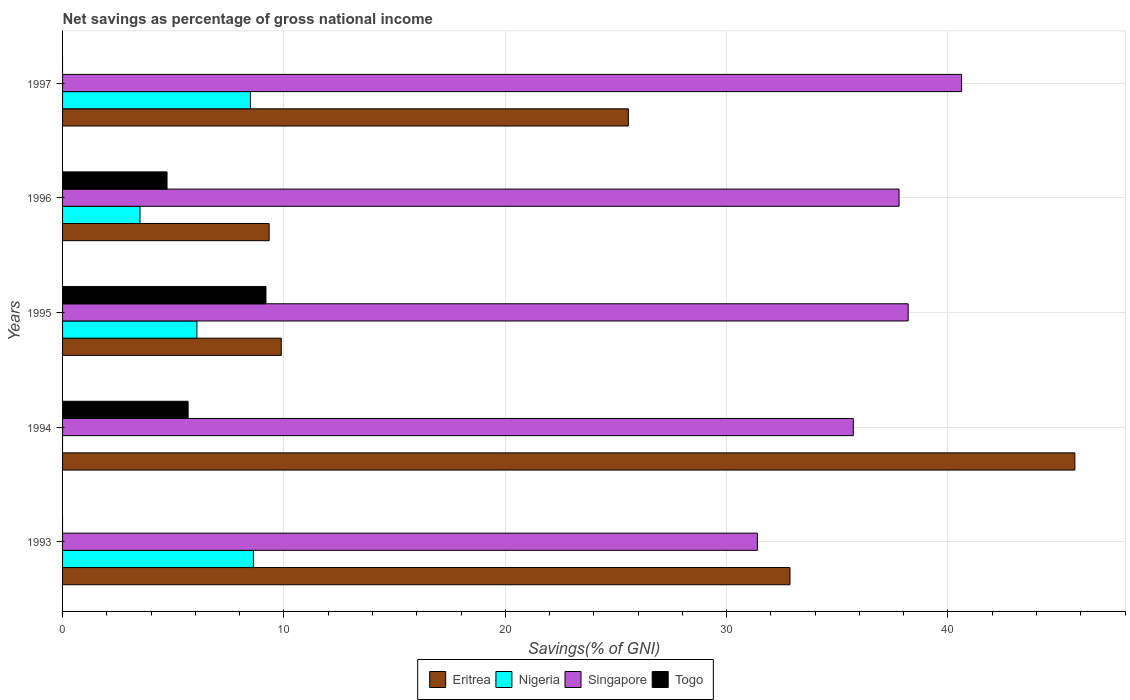How many bars are there on the 3rd tick from the top?
Give a very brief answer. 4. How many bars are there on the 5th tick from the bottom?
Provide a short and direct response. 3. What is the label of the 5th group of bars from the top?
Your answer should be compact. 1993. What is the total savings in Eritrea in 1995?
Provide a succinct answer. 9.88. Across all years, what is the maximum total savings in Togo?
Provide a succinct answer. 9.19. In which year was the total savings in Singapore maximum?
Make the answer very short. 1997. What is the total total savings in Singapore in the graph?
Offer a terse response. 183.72. What is the difference between the total savings in Eritrea in 1993 and that in 1995?
Give a very brief answer. 22.98. What is the difference between the total savings in Singapore in 1996 and the total savings in Nigeria in 1995?
Provide a succinct answer. 31.72. What is the average total savings in Eritrea per year?
Ensure brevity in your answer.  24.67. In the year 1994, what is the difference between the total savings in Togo and total savings in Singapore?
Your response must be concise. -30.05. In how many years, is the total savings in Singapore greater than 14 %?
Offer a terse response. 5. What is the ratio of the total savings in Eritrea in 1994 to that in 1996?
Ensure brevity in your answer.  4.9. What is the difference between the highest and the second highest total savings in Togo?
Ensure brevity in your answer.  3.52. What is the difference between the highest and the lowest total savings in Singapore?
Ensure brevity in your answer.  9.23. Is the sum of the total savings in Singapore in 1993 and 1994 greater than the maximum total savings in Togo across all years?
Offer a terse response. Yes. Is it the case that in every year, the sum of the total savings in Eritrea and total savings in Nigeria is greater than the total savings in Singapore?
Your response must be concise. No. How many bars are there?
Offer a very short reply. 17. Are all the bars in the graph horizontal?
Offer a terse response. Yes. Does the graph contain any zero values?
Provide a succinct answer. Yes. Does the graph contain grids?
Ensure brevity in your answer.  Yes. How many legend labels are there?
Provide a succinct answer. 4. What is the title of the graph?
Your answer should be very brief. Net savings as percentage of gross national income. Does "Other small states" appear as one of the legend labels in the graph?
Ensure brevity in your answer.  No. What is the label or title of the X-axis?
Make the answer very short. Savings(% of GNI). What is the label or title of the Y-axis?
Make the answer very short. Years. What is the Savings(% of GNI) in Eritrea in 1993?
Keep it short and to the point. 32.86. What is the Savings(% of GNI) of Nigeria in 1993?
Your response must be concise. 8.62. What is the Savings(% of GNI) in Singapore in 1993?
Offer a very short reply. 31.39. What is the Savings(% of GNI) of Togo in 1993?
Keep it short and to the point. 0. What is the Savings(% of GNI) of Eritrea in 1994?
Offer a very short reply. 45.73. What is the Savings(% of GNI) in Nigeria in 1994?
Provide a short and direct response. 0. What is the Savings(% of GNI) of Singapore in 1994?
Your answer should be compact. 35.72. What is the Savings(% of GNI) in Togo in 1994?
Your answer should be very brief. 5.67. What is the Savings(% of GNI) in Eritrea in 1995?
Your answer should be very brief. 9.88. What is the Savings(% of GNI) of Nigeria in 1995?
Your response must be concise. 6.07. What is the Savings(% of GNI) in Singapore in 1995?
Offer a terse response. 38.2. What is the Savings(% of GNI) in Togo in 1995?
Keep it short and to the point. 9.19. What is the Savings(% of GNI) of Eritrea in 1996?
Offer a terse response. 9.33. What is the Savings(% of GNI) of Nigeria in 1996?
Ensure brevity in your answer.  3.5. What is the Savings(% of GNI) of Singapore in 1996?
Offer a very short reply. 37.79. What is the Savings(% of GNI) of Togo in 1996?
Provide a succinct answer. 4.72. What is the Savings(% of GNI) in Eritrea in 1997?
Your response must be concise. 25.56. What is the Savings(% of GNI) in Nigeria in 1997?
Offer a terse response. 8.49. What is the Savings(% of GNI) of Singapore in 1997?
Keep it short and to the point. 40.62. What is the Savings(% of GNI) of Togo in 1997?
Your answer should be very brief. 0. Across all years, what is the maximum Savings(% of GNI) of Eritrea?
Your answer should be very brief. 45.73. Across all years, what is the maximum Savings(% of GNI) of Nigeria?
Your answer should be very brief. 8.62. Across all years, what is the maximum Savings(% of GNI) of Singapore?
Give a very brief answer. 40.62. Across all years, what is the maximum Savings(% of GNI) in Togo?
Give a very brief answer. 9.19. Across all years, what is the minimum Savings(% of GNI) in Eritrea?
Offer a very short reply. 9.33. Across all years, what is the minimum Savings(% of GNI) in Singapore?
Provide a short and direct response. 31.39. Across all years, what is the minimum Savings(% of GNI) in Togo?
Your answer should be very brief. 0. What is the total Savings(% of GNI) in Eritrea in the graph?
Keep it short and to the point. 123.37. What is the total Savings(% of GNI) in Nigeria in the graph?
Provide a short and direct response. 26.68. What is the total Savings(% of GNI) of Singapore in the graph?
Provide a short and direct response. 183.72. What is the total Savings(% of GNI) in Togo in the graph?
Ensure brevity in your answer.  19.58. What is the difference between the Savings(% of GNI) in Eritrea in 1993 and that in 1994?
Keep it short and to the point. -12.87. What is the difference between the Savings(% of GNI) of Singapore in 1993 and that in 1994?
Your answer should be compact. -4.33. What is the difference between the Savings(% of GNI) of Eritrea in 1993 and that in 1995?
Ensure brevity in your answer.  22.98. What is the difference between the Savings(% of GNI) in Nigeria in 1993 and that in 1995?
Provide a succinct answer. 2.55. What is the difference between the Savings(% of GNI) of Singapore in 1993 and that in 1995?
Make the answer very short. -6.81. What is the difference between the Savings(% of GNI) in Eritrea in 1993 and that in 1996?
Provide a short and direct response. 23.53. What is the difference between the Savings(% of GNI) of Nigeria in 1993 and that in 1996?
Make the answer very short. 5.12. What is the difference between the Savings(% of GNI) of Singapore in 1993 and that in 1996?
Keep it short and to the point. -6.4. What is the difference between the Savings(% of GNI) in Eritrea in 1993 and that in 1997?
Offer a very short reply. 7.3. What is the difference between the Savings(% of GNI) of Nigeria in 1993 and that in 1997?
Ensure brevity in your answer.  0.14. What is the difference between the Savings(% of GNI) in Singapore in 1993 and that in 1997?
Ensure brevity in your answer.  -9.23. What is the difference between the Savings(% of GNI) in Eritrea in 1994 and that in 1995?
Offer a terse response. 35.85. What is the difference between the Savings(% of GNI) in Singapore in 1994 and that in 1995?
Provide a succinct answer. -2.48. What is the difference between the Savings(% of GNI) of Togo in 1994 and that in 1995?
Your response must be concise. -3.52. What is the difference between the Savings(% of GNI) of Eritrea in 1994 and that in 1996?
Make the answer very short. 36.4. What is the difference between the Savings(% of GNI) in Singapore in 1994 and that in 1996?
Offer a terse response. -2.07. What is the difference between the Savings(% of GNI) of Togo in 1994 and that in 1996?
Your response must be concise. 0.95. What is the difference between the Savings(% of GNI) in Eritrea in 1994 and that in 1997?
Your response must be concise. 20.17. What is the difference between the Savings(% of GNI) of Singapore in 1994 and that in 1997?
Your answer should be compact. -4.89. What is the difference between the Savings(% of GNI) of Eritrea in 1995 and that in 1996?
Provide a succinct answer. 0.55. What is the difference between the Savings(% of GNI) of Nigeria in 1995 and that in 1996?
Give a very brief answer. 2.57. What is the difference between the Savings(% of GNI) of Singapore in 1995 and that in 1996?
Keep it short and to the point. 0.41. What is the difference between the Savings(% of GNI) in Togo in 1995 and that in 1996?
Your answer should be very brief. 4.47. What is the difference between the Savings(% of GNI) in Eritrea in 1995 and that in 1997?
Give a very brief answer. -15.68. What is the difference between the Savings(% of GNI) of Nigeria in 1995 and that in 1997?
Ensure brevity in your answer.  -2.42. What is the difference between the Savings(% of GNI) of Singapore in 1995 and that in 1997?
Your answer should be very brief. -2.41. What is the difference between the Savings(% of GNI) of Eritrea in 1996 and that in 1997?
Offer a very short reply. -16.23. What is the difference between the Savings(% of GNI) of Nigeria in 1996 and that in 1997?
Ensure brevity in your answer.  -4.99. What is the difference between the Savings(% of GNI) of Singapore in 1996 and that in 1997?
Keep it short and to the point. -2.83. What is the difference between the Savings(% of GNI) of Eritrea in 1993 and the Savings(% of GNI) of Singapore in 1994?
Provide a short and direct response. -2.86. What is the difference between the Savings(% of GNI) in Eritrea in 1993 and the Savings(% of GNI) in Togo in 1994?
Ensure brevity in your answer.  27.19. What is the difference between the Savings(% of GNI) in Nigeria in 1993 and the Savings(% of GNI) in Singapore in 1994?
Offer a terse response. -27.1. What is the difference between the Savings(% of GNI) of Nigeria in 1993 and the Savings(% of GNI) of Togo in 1994?
Your answer should be compact. 2.95. What is the difference between the Savings(% of GNI) of Singapore in 1993 and the Savings(% of GNI) of Togo in 1994?
Offer a terse response. 25.72. What is the difference between the Savings(% of GNI) in Eritrea in 1993 and the Savings(% of GNI) in Nigeria in 1995?
Your answer should be compact. 26.79. What is the difference between the Savings(% of GNI) of Eritrea in 1993 and the Savings(% of GNI) of Singapore in 1995?
Your answer should be very brief. -5.34. What is the difference between the Savings(% of GNI) in Eritrea in 1993 and the Savings(% of GNI) in Togo in 1995?
Make the answer very short. 23.67. What is the difference between the Savings(% of GNI) of Nigeria in 1993 and the Savings(% of GNI) of Singapore in 1995?
Offer a very short reply. -29.58. What is the difference between the Savings(% of GNI) of Nigeria in 1993 and the Savings(% of GNI) of Togo in 1995?
Keep it short and to the point. -0.57. What is the difference between the Savings(% of GNI) of Singapore in 1993 and the Savings(% of GNI) of Togo in 1995?
Keep it short and to the point. 22.2. What is the difference between the Savings(% of GNI) of Eritrea in 1993 and the Savings(% of GNI) of Nigeria in 1996?
Keep it short and to the point. 29.36. What is the difference between the Savings(% of GNI) in Eritrea in 1993 and the Savings(% of GNI) in Singapore in 1996?
Provide a short and direct response. -4.93. What is the difference between the Savings(% of GNI) of Eritrea in 1993 and the Savings(% of GNI) of Togo in 1996?
Offer a terse response. 28.14. What is the difference between the Savings(% of GNI) in Nigeria in 1993 and the Savings(% of GNI) in Singapore in 1996?
Your response must be concise. -29.17. What is the difference between the Savings(% of GNI) in Nigeria in 1993 and the Savings(% of GNI) in Togo in 1996?
Your response must be concise. 3.9. What is the difference between the Savings(% of GNI) of Singapore in 1993 and the Savings(% of GNI) of Togo in 1996?
Offer a terse response. 26.67. What is the difference between the Savings(% of GNI) in Eritrea in 1993 and the Savings(% of GNI) in Nigeria in 1997?
Your answer should be very brief. 24.38. What is the difference between the Savings(% of GNI) of Eritrea in 1993 and the Savings(% of GNI) of Singapore in 1997?
Ensure brevity in your answer.  -7.75. What is the difference between the Savings(% of GNI) of Nigeria in 1993 and the Savings(% of GNI) of Singapore in 1997?
Keep it short and to the point. -31.99. What is the difference between the Savings(% of GNI) of Eritrea in 1994 and the Savings(% of GNI) of Nigeria in 1995?
Make the answer very short. 39.66. What is the difference between the Savings(% of GNI) of Eritrea in 1994 and the Savings(% of GNI) of Singapore in 1995?
Give a very brief answer. 7.53. What is the difference between the Savings(% of GNI) in Eritrea in 1994 and the Savings(% of GNI) in Togo in 1995?
Make the answer very short. 36.54. What is the difference between the Savings(% of GNI) in Singapore in 1994 and the Savings(% of GNI) in Togo in 1995?
Your answer should be compact. 26.53. What is the difference between the Savings(% of GNI) in Eritrea in 1994 and the Savings(% of GNI) in Nigeria in 1996?
Your answer should be compact. 42.23. What is the difference between the Savings(% of GNI) of Eritrea in 1994 and the Savings(% of GNI) of Singapore in 1996?
Keep it short and to the point. 7.94. What is the difference between the Savings(% of GNI) of Eritrea in 1994 and the Savings(% of GNI) of Togo in 1996?
Give a very brief answer. 41.01. What is the difference between the Savings(% of GNI) of Singapore in 1994 and the Savings(% of GNI) of Togo in 1996?
Provide a short and direct response. 31. What is the difference between the Savings(% of GNI) in Eritrea in 1994 and the Savings(% of GNI) in Nigeria in 1997?
Offer a very short reply. 37.25. What is the difference between the Savings(% of GNI) in Eritrea in 1994 and the Savings(% of GNI) in Singapore in 1997?
Ensure brevity in your answer.  5.12. What is the difference between the Savings(% of GNI) of Eritrea in 1995 and the Savings(% of GNI) of Nigeria in 1996?
Your response must be concise. 6.38. What is the difference between the Savings(% of GNI) in Eritrea in 1995 and the Savings(% of GNI) in Singapore in 1996?
Provide a short and direct response. -27.91. What is the difference between the Savings(% of GNI) in Eritrea in 1995 and the Savings(% of GNI) in Togo in 1996?
Your response must be concise. 5.16. What is the difference between the Savings(% of GNI) of Nigeria in 1995 and the Savings(% of GNI) of Singapore in 1996?
Ensure brevity in your answer.  -31.72. What is the difference between the Savings(% of GNI) of Nigeria in 1995 and the Savings(% of GNI) of Togo in 1996?
Give a very brief answer. 1.35. What is the difference between the Savings(% of GNI) of Singapore in 1995 and the Savings(% of GNI) of Togo in 1996?
Provide a succinct answer. 33.48. What is the difference between the Savings(% of GNI) of Eritrea in 1995 and the Savings(% of GNI) of Nigeria in 1997?
Keep it short and to the point. 1.4. What is the difference between the Savings(% of GNI) in Eritrea in 1995 and the Savings(% of GNI) in Singapore in 1997?
Make the answer very short. -30.74. What is the difference between the Savings(% of GNI) of Nigeria in 1995 and the Savings(% of GNI) of Singapore in 1997?
Your answer should be compact. -34.55. What is the difference between the Savings(% of GNI) in Eritrea in 1996 and the Savings(% of GNI) in Nigeria in 1997?
Provide a succinct answer. 0.85. What is the difference between the Savings(% of GNI) of Eritrea in 1996 and the Savings(% of GNI) of Singapore in 1997?
Your response must be concise. -31.28. What is the difference between the Savings(% of GNI) of Nigeria in 1996 and the Savings(% of GNI) of Singapore in 1997?
Provide a succinct answer. -37.12. What is the average Savings(% of GNI) of Eritrea per year?
Provide a short and direct response. 24.67. What is the average Savings(% of GNI) in Nigeria per year?
Provide a short and direct response. 5.34. What is the average Savings(% of GNI) in Singapore per year?
Make the answer very short. 36.74. What is the average Savings(% of GNI) of Togo per year?
Make the answer very short. 3.92. In the year 1993, what is the difference between the Savings(% of GNI) of Eritrea and Savings(% of GNI) of Nigeria?
Ensure brevity in your answer.  24.24. In the year 1993, what is the difference between the Savings(% of GNI) of Eritrea and Savings(% of GNI) of Singapore?
Your response must be concise. 1.47. In the year 1993, what is the difference between the Savings(% of GNI) in Nigeria and Savings(% of GNI) in Singapore?
Keep it short and to the point. -22.77. In the year 1994, what is the difference between the Savings(% of GNI) in Eritrea and Savings(% of GNI) in Singapore?
Your response must be concise. 10.01. In the year 1994, what is the difference between the Savings(% of GNI) in Eritrea and Savings(% of GNI) in Togo?
Ensure brevity in your answer.  40.06. In the year 1994, what is the difference between the Savings(% of GNI) in Singapore and Savings(% of GNI) in Togo?
Provide a short and direct response. 30.05. In the year 1995, what is the difference between the Savings(% of GNI) in Eritrea and Savings(% of GNI) in Nigeria?
Provide a succinct answer. 3.81. In the year 1995, what is the difference between the Savings(% of GNI) of Eritrea and Savings(% of GNI) of Singapore?
Ensure brevity in your answer.  -28.32. In the year 1995, what is the difference between the Savings(% of GNI) of Eritrea and Savings(% of GNI) of Togo?
Ensure brevity in your answer.  0.69. In the year 1995, what is the difference between the Savings(% of GNI) in Nigeria and Savings(% of GNI) in Singapore?
Your answer should be compact. -32.13. In the year 1995, what is the difference between the Savings(% of GNI) in Nigeria and Savings(% of GNI) in Togo?
Ensure brevity in your answer.  -3.12. In the year 1995, what is the difference between the Savings(% of GNI) in Singapore and Savings(% of GNI) in Togo?
Provide a short and direct response. 29.01. In the year 1996, what is the difference between the Savings(% of GNI) of Eritrea and Savings(% of GNI) of Nigeria?
Ensure brevity in your answer.  5.83. In the year 1996, what is the difference between the Savings(% of GNI) of Eritrea and Savings(% of GNI) of Singapore?
Your answer should be compact. -28.46. In the year 1996, what is the difference between the Savings(% of GNI) of Eritrea and Savings(% of GNI) of Togo?
Keep it short and to the point. 4.61. In the year 1996, what is the difference between the Savings(% of GNI) of Nigeria and Savings(% of GNI) of Singapore?
Give a very brief answer. -34.29. In the year 1996, what is the difference between the Savings(% of GNI) in Nigeria and Savings(% of GNI) in Togo?
Provide a succinct answer. -1.22. In the year 1996, what is the difference between the Savings(% of GNI) of Singapore and Savings(% of GNI) of Togo?
Your response must be concise. 33.07. In the year 1997, what is the difference between the Savings(% of GNI) in Eritrea and Savings(% of GNI) in Nigeria?
Offer a terse response. 17.08. In the year 1997, what is the difference between the Savings(% of GNI) of Eritrea and Savings(% of GNI) of Singapore?
Your answer should be very brief. -15.05. In the year 1997, what is the difference between the Savings(% of GNI) in Nigeria and Savings(% of GNI) in Singapore?
Your answer should be compact. -32.13. What is the ratio of the Savings(% of GNI) in Eritrea in 1993 to that in 1994?
Ensure brevity in your answer.  0.72. What is the ratio of the Savings(% of GNI) of Singapore in 1993 to that in 1994?
Provide a short and direct response. 0.88. What is the ratio of the Savings(% of GNI) in Eritrea in 1993 to that in 1995?
Offer a very short reply. 3.33. What is the ratio of the Savings(% of GNI) in Nigeria in 1993 to that in 1995?
Make the answer very short. 1.42. What is the ratio of the Savings(% of GNI) of Singapore in 1993 to that in 1995?
Keep it short and to the point. 0.82. What is the ratio of the Savings(% of GNI) in Eritrea in 1993 to that in 1996?
Make the answer very short. 3.52. What is the ratio of the Savings(% of GNI) in Nigeria in 1993 to that in 1996?
Your response must be concise. 2.46. What is the ratio of the Savings(% of GNI) of Singapore in 1993 to that in 1996?
Make the answer very short. 0.83. What is the ratio of the Savings(% of GNI) in Eritrea in 1993 to that in 1997?
Keep it short and to the point. 1.29. What is the ratio of the Savings(% of GNI) of Nigeria in 1993 to that in 1997?
Offer a very short reply. 1.02. What is the ratio of the Savings(% of GNI) of Singapore in 1993 to that in 1997?
Offer a very short reply. 0.77. What is the ratio of the Savings(% of GNI) in Eritrea in 1994 to that in 1995?
Offer a terse response. 4.63. What is the ratio of the Savings(% of GNI) of Singapore in 1994 to that in 1995?
Your response must be concise. 0.94. What is the ratio of the Savings(% of GNI) of Togo in 1994 to that in 1995?
Your response must be concise. 0.62. What is the ratio of the Savings(% of GNI) in Eritrea in 1994 to that in 1996?
Provide a short and direct response. 4.9. What is the ratio of the Savings(% of GNI) of Singapore in 1994 to that in 1996?
Your answer should be very brief. 0.95. What is the ratio of the Savings(% of GNI) of Togo in 1994 to that in 1996?
Your response must be concise. 1.2. What is the ratio of the Savings(% of GNI) in Eritrea in 1994 to that in 1997?
Keep it short and to the point. 1.79. What is the ratio of the Savings(% of GNI) in Singapore in 1994 to that in 1997?
Keep it short and to the point. 0.88. What is the ratio of the Savings(% of GNI) of Eritrea in 1995 to that in 1996?
Provide a short and direct response. 1.06. What is the ratio of the Savings(% of GNI) in Nigeria in 1995 to that in 1996?
Your answer should be very brief. 1.73. What is the ratio of the Savings(% of GNI) of Singapore in 1995 to that in 1996?
Give a very brief answer. 1.01. What is the ratio of the Savings(% of GNI) of Togo in 1995 to that in 1996?
Provide a succinct answer. 1.95. What is the ratio of the Savings(% of GNI) in Eritrea in 1995 to that in 1997?
Provide a short and direct response. 0.39. What is the ratio of the Savings(% of GNI) in Nigeria in 1995 to that in 1997?
Keep it short and to the point. 0.72. What is the ratio of the Savings(% of GNI) in Singapore in 1995 to that in 1997?
Provide a succinct answer. 0.94. What is the ratio of the Savings(% of GNI) in Eritrea in 1996 to that in 1997?
Keep it short and to the point. 0.37. What is the ratio of the Savings(% of GNI) of Nigeria in 1996 to that in 1997?
Your answer should be very brief. 0.41. What is the ratio of the Savings(% of GNI) in Singapore in 1996 to that in 1997?
Provide a short and direct response. 0.93. What is the difference between the highest and the second highest Savings(% of GNI) of Eritrea?
Give a very brief answer. 12.87. What is the difference between the highest and the second highest Savings(% of GNI) in Nigeria?
Provide a short and direct response. 0.14. What is the difference between the highest and the second highest Savings(% of GNI) in Singapore?
Make the answer very short. 2.41. What is the difference between the highest and the second highest Savings(% of GNI) in Togo?
Your answer should be very brief. 3.52. What is the difference between the highest and the lowest Savings(% of GNI) in Eritrea?
Your answer should be compact. 36.4. What is the difference between the highest and the lowest Savings(% of GNI) in Nigeria?
Provide a succinct answer. 8.62. What is the difference between the highest and the lowest Savings(% of GNI) in Singapore?
Provide a short and direct response. 9.23. What is the difference between the highest and the lowest Savings(% of GNI) of Togo?
Give a very brief answer. 9.19. 